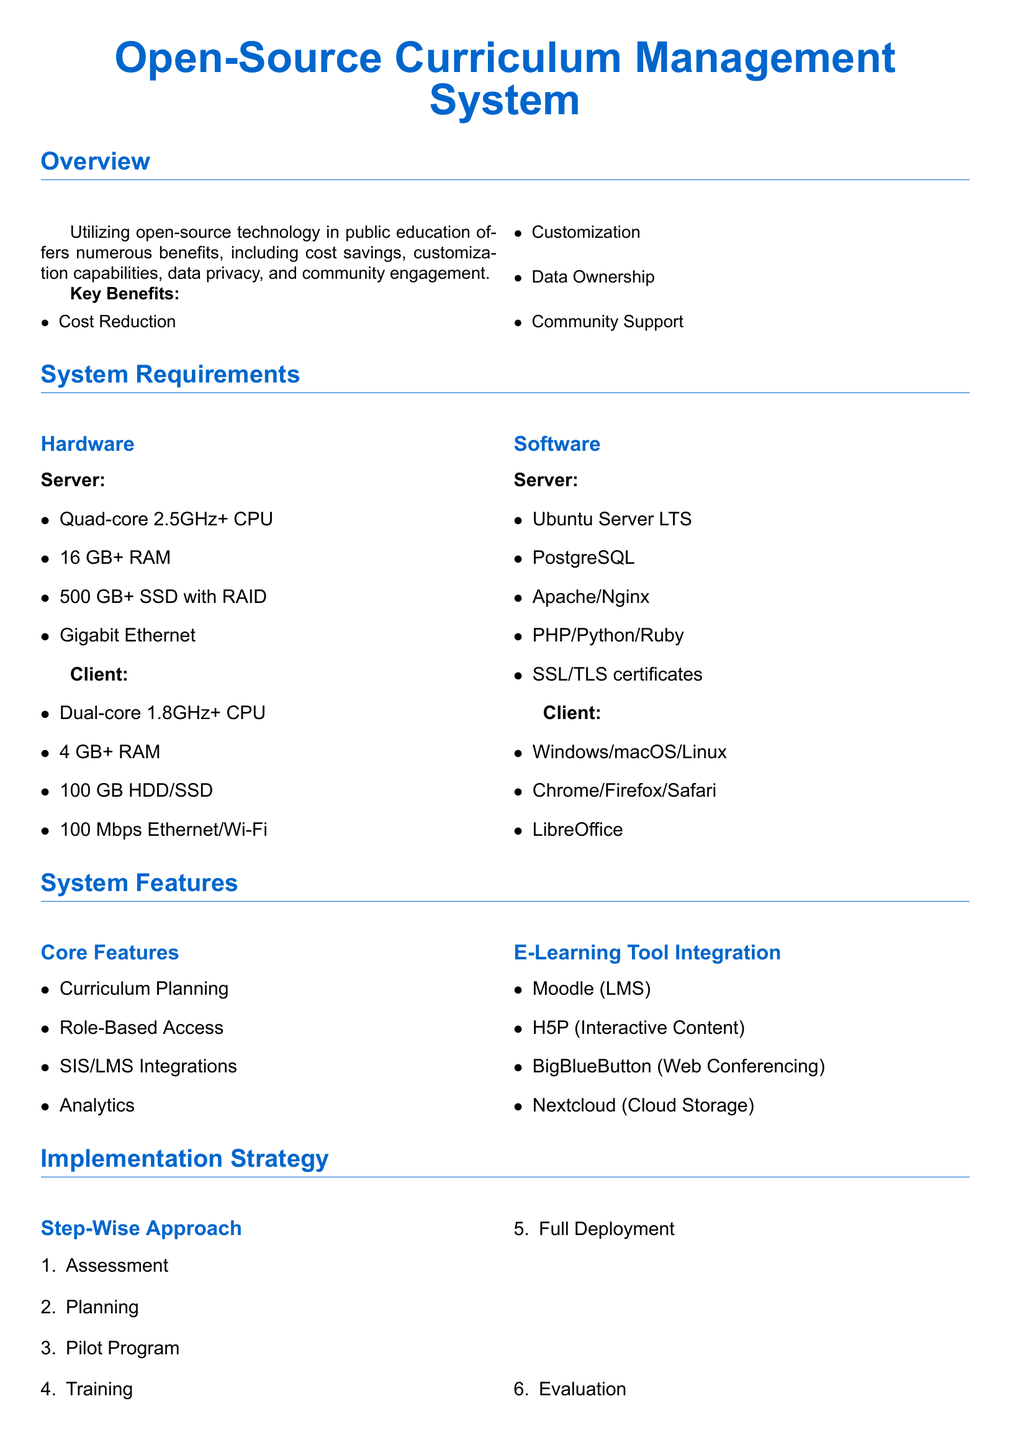What are the key benefits of utilizing open-source technology? The key benefits are listed in the document as cost reduction, customization, data ownership, and community support.
Answer: Cost Reduction, Customization, Data Ownership, Community Support What is the recommended server CPU for the system? The specified requirement for the server CPU is a quad-core processor with a speed of 2.5GHz or higher.
Answer: Quad-core 2.5GHz+ How many GB of RAM is required for the server? The document states that 16 GB of RAM or more is required for the server specifications.
Answer: 16 GB+ What are some e-learning tools integrated into the system? The document lists tools such as Moodle, H5P, BigBlueButton, and Nextcloud as integrated e-learning tools.
Answer: Moodle, H5P, BigBlueButton, Nextcloud What is the step that comes after the pilot program in the implementation strategy? The implementation strategy outlines training after the pilot program, indicating the sequence of steps.
Answer: Training What is one of the key considerations mentioned for implementation? The document highlights data migration as one of the key considerations for the implementation process.
Answer: Data Migration 